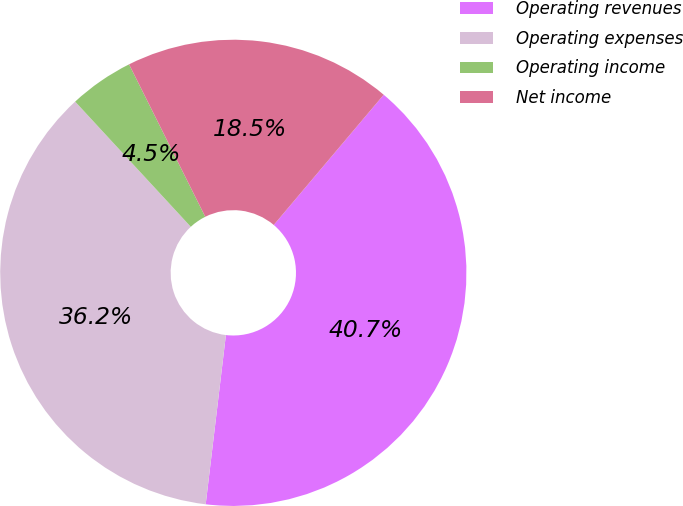<chart> <loc_0><loc_0><loc_500><loc_500><pie_chart><fcel>Operating revenues<fcel>Operating expenses<fcel>Operating income<fcel>Net income<nl><fcel>40.73%<fcel>36.24%<fcel>4.49%<fcel>18.54%<nl></chart> 